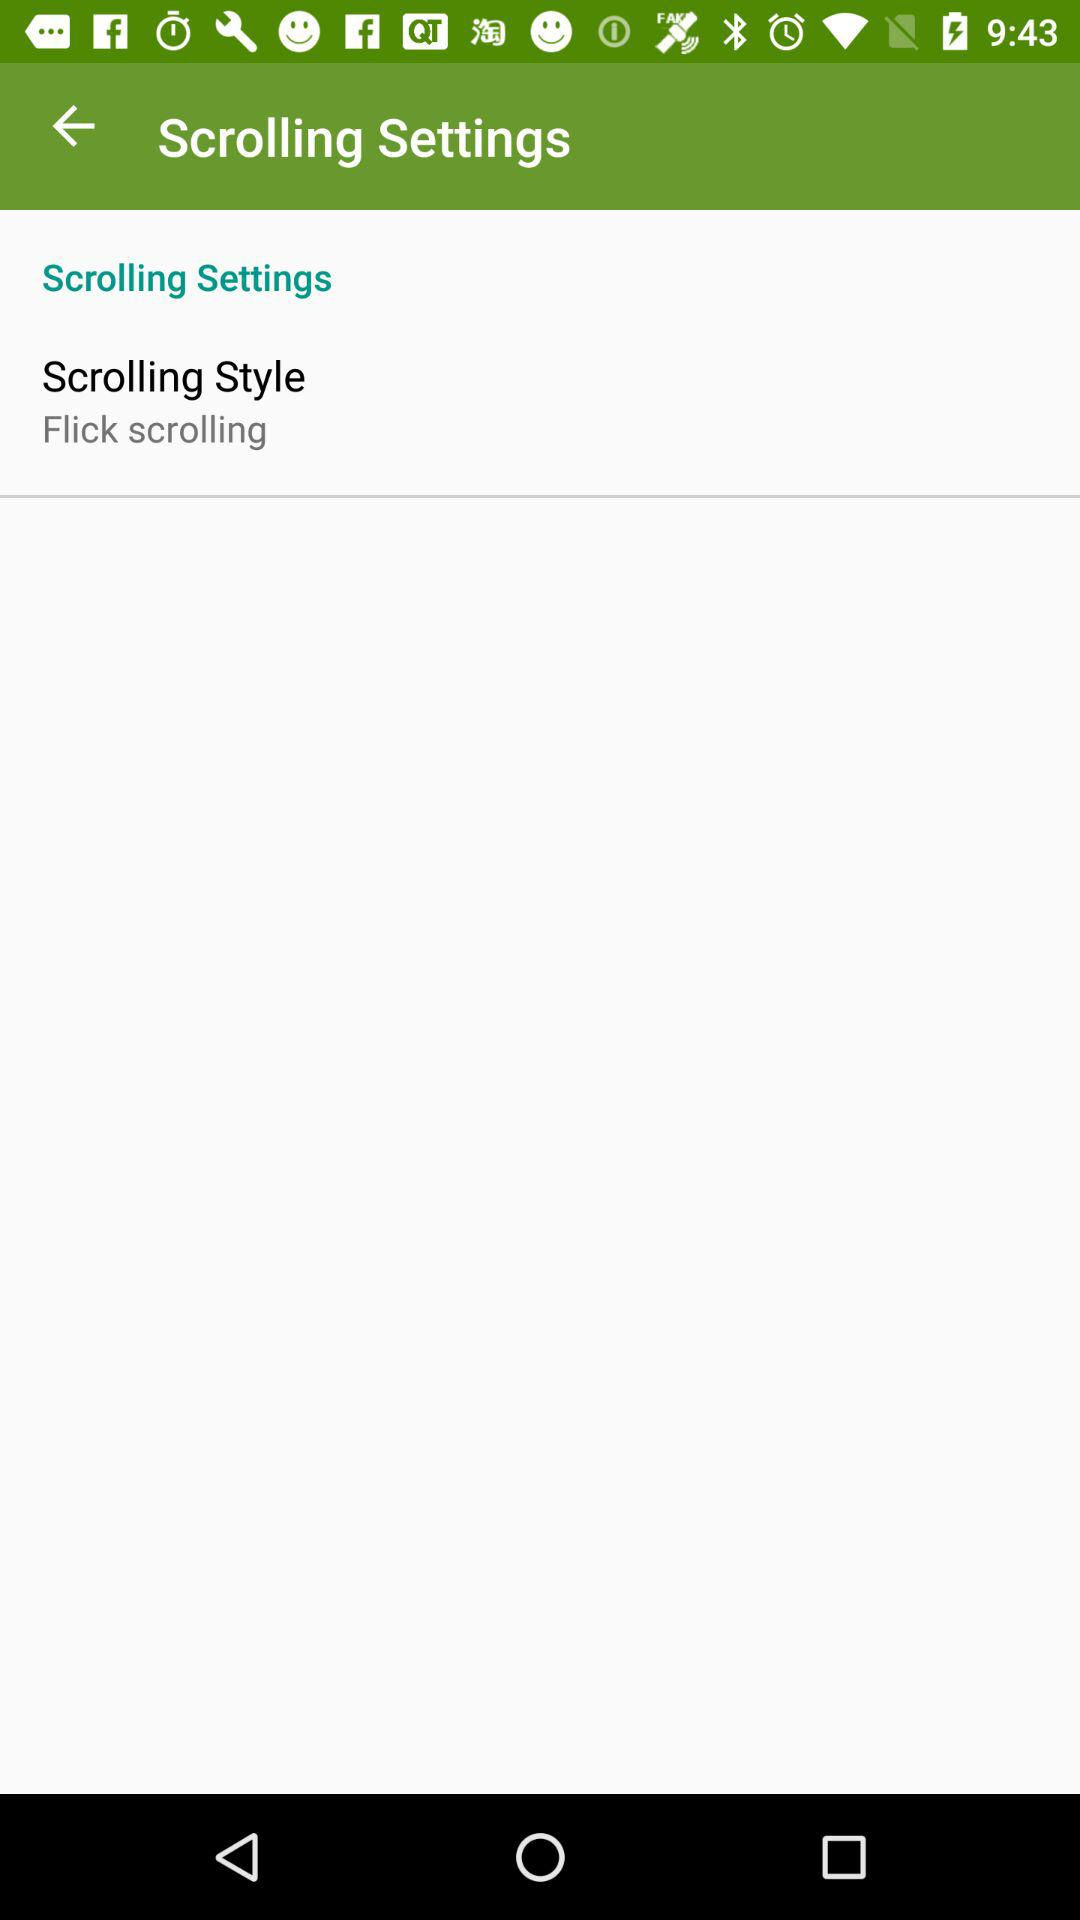Which scrolling style is set? The set scrolling style is "Flick scrolling". 